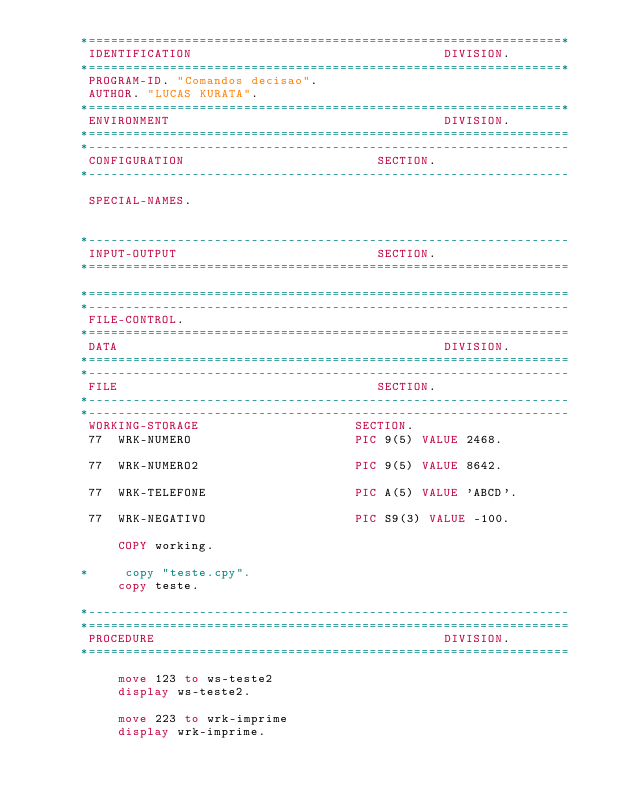<code> <loc_0><loc_0><loc_500><loc_500><_COBOL_>      *================================================================*
       IDENTIFICATION                                  DIVISION.
      *================================================================*
       PROGRAM-ID. "Comandos decisao".
       AUTHOR. "LUCAS KURATA".
      *================================================================*
       ENVIRONMENT                                     DIVISION.
      *=================================================================
      *-----------------------------------------------------------------
       CONFIGURATION                          SECTION.
      *-----------------------------------------------------------------

       SPECIAL-NAMES.


      *-----------------------------------------------------------------
       INPUT-OUTPUT                           SECTION.
      *=================================================================

      *=================================================================
      *-----------------------------------------------------------------
       FILE-CONTROL.
      *=================================================================
       DATA                                            DIVISION.
      *=================================================================
      *-----------------------------------------------------------------
       FILE                                   SECTION.
      *-----------------------------------------------------------------
      *-----------------------------------------------------------------
       WORKING-STORAGE                     SECTION.
       77  WRK-NUMERO                      PIC 9(5) VALUE 2468.

       77  WRK-NUMERO2                     PIC 9(5) VALUE 8642.

       77  WRK-TELEFONE                    PIC A(5) VALUE 'ABCD'.

       77  WRK-NEGATIVO                    PIC S9(3) VALUE -100.

           COPY working.

      *     copy "teste.cpy".
           copy teste.

      *-----------------------------------------------------------------
      *=================================================================
       PROCEDURE                                       DIVISION.
      *=================================================================

           move 123 to ws-teste2
           display ws-teste2.

           move 223 to wrk-imprime
           display wrk-imprime.
</code> 